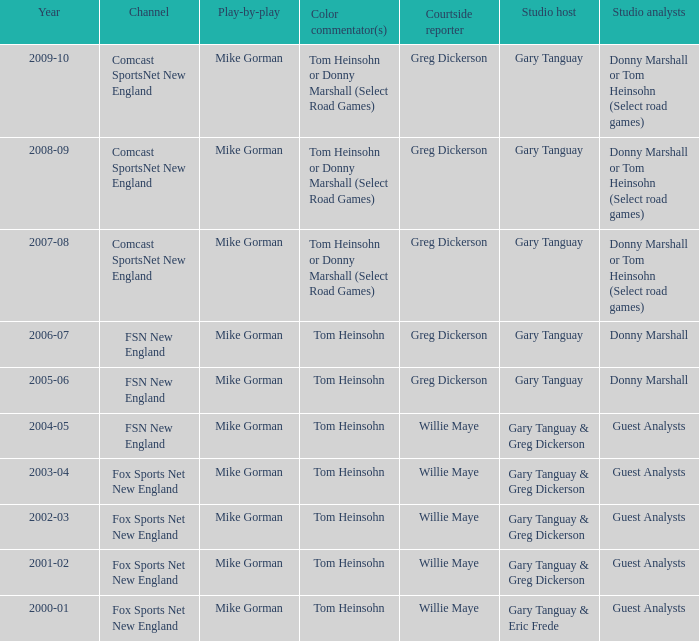Who was the studio host during the 2003-04 year? Gary Tanguay & Greg Dickerson. 